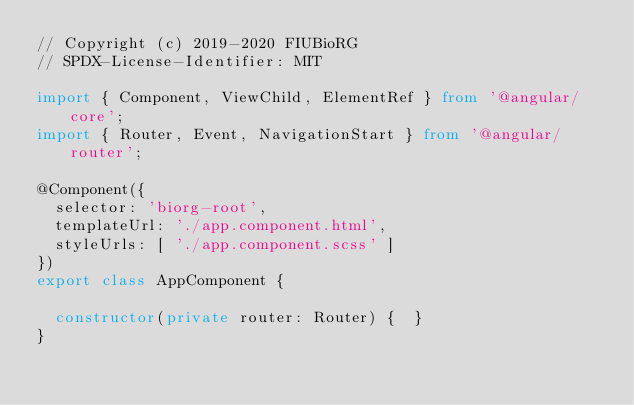<code> <loc_0><loc_0><loc_500><loc_500><_TypeScript_>// Copyright (c) 2019-2020 FIUBioRG
// SPDX-License-Identifier: MIT

import { Component, ViewChild, ElementRef } from '@angular/core';
import { Router, Event, NavigationStart } from '@angular/router';

@Component({
  selector: 'biorg-root',
  templateUrl: './app.component.html',
  styleUrls: [ './app.component.scss' ]
})
export class AppComponent {

  constructor(private router: Router) {  }
}
</code> 